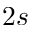<formula> <loc_0><loc_0><loc_500><loc_500>2 s</formula> 